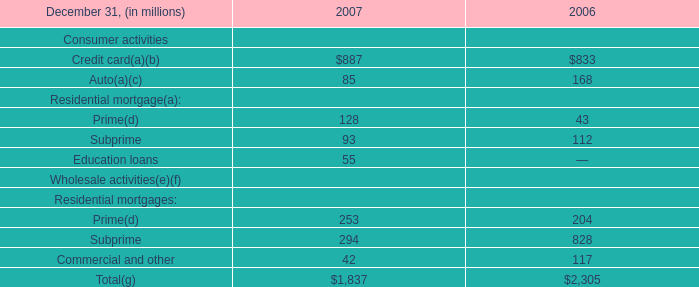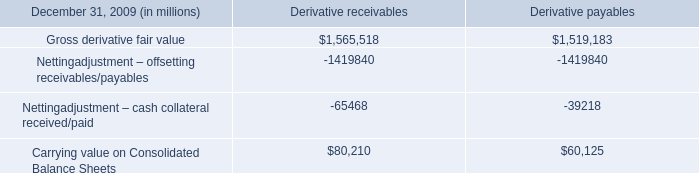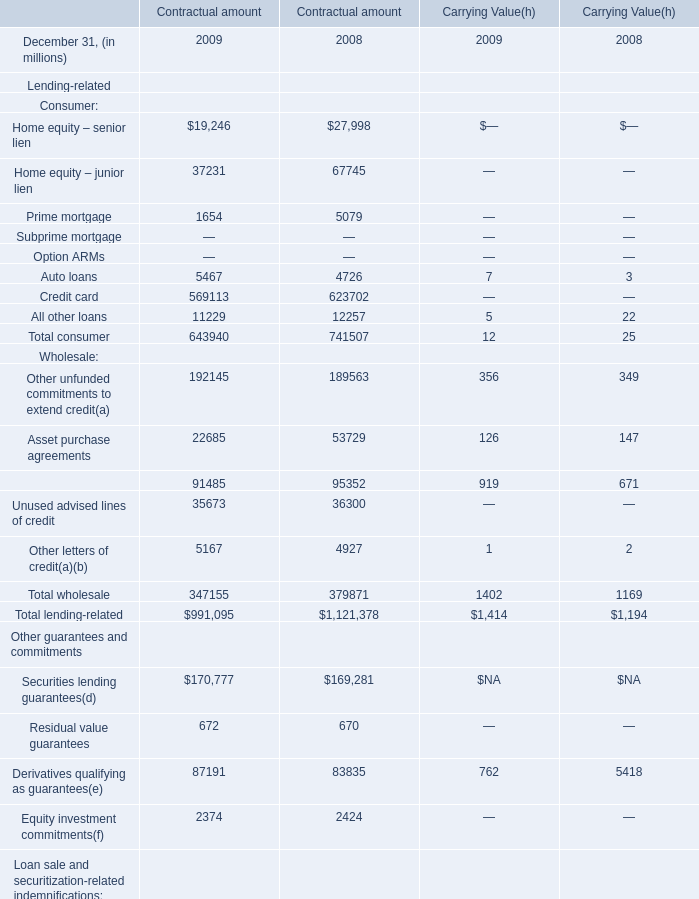What was the average amount for the Total lending-related, the Total wholesale, the Derivatives qualifying as guarantees in 2009 at Carrying Value ? (in million) 
Computations: (((1414 + 1402) + 762) / 3)
Answer: 1192.66667. 